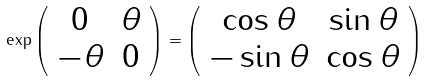<formula> <loc_0><loc_0><loc_500><loc_500>\exp \left ( \begin{array} { c c c } 0 & \theta \\ - \theta & 0 \end{array} \right ) = \left ( \begin{array} { c c c } \cos \theta & \sin \theta \\ - \sin \theta & \cos \theta \end{array} \right )</formula> 